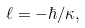Convert formula to latex. <formula><loc_0><loc_0><loc_500><loc_500>\ell = - \hbar { / } \kappa ,</formula> 